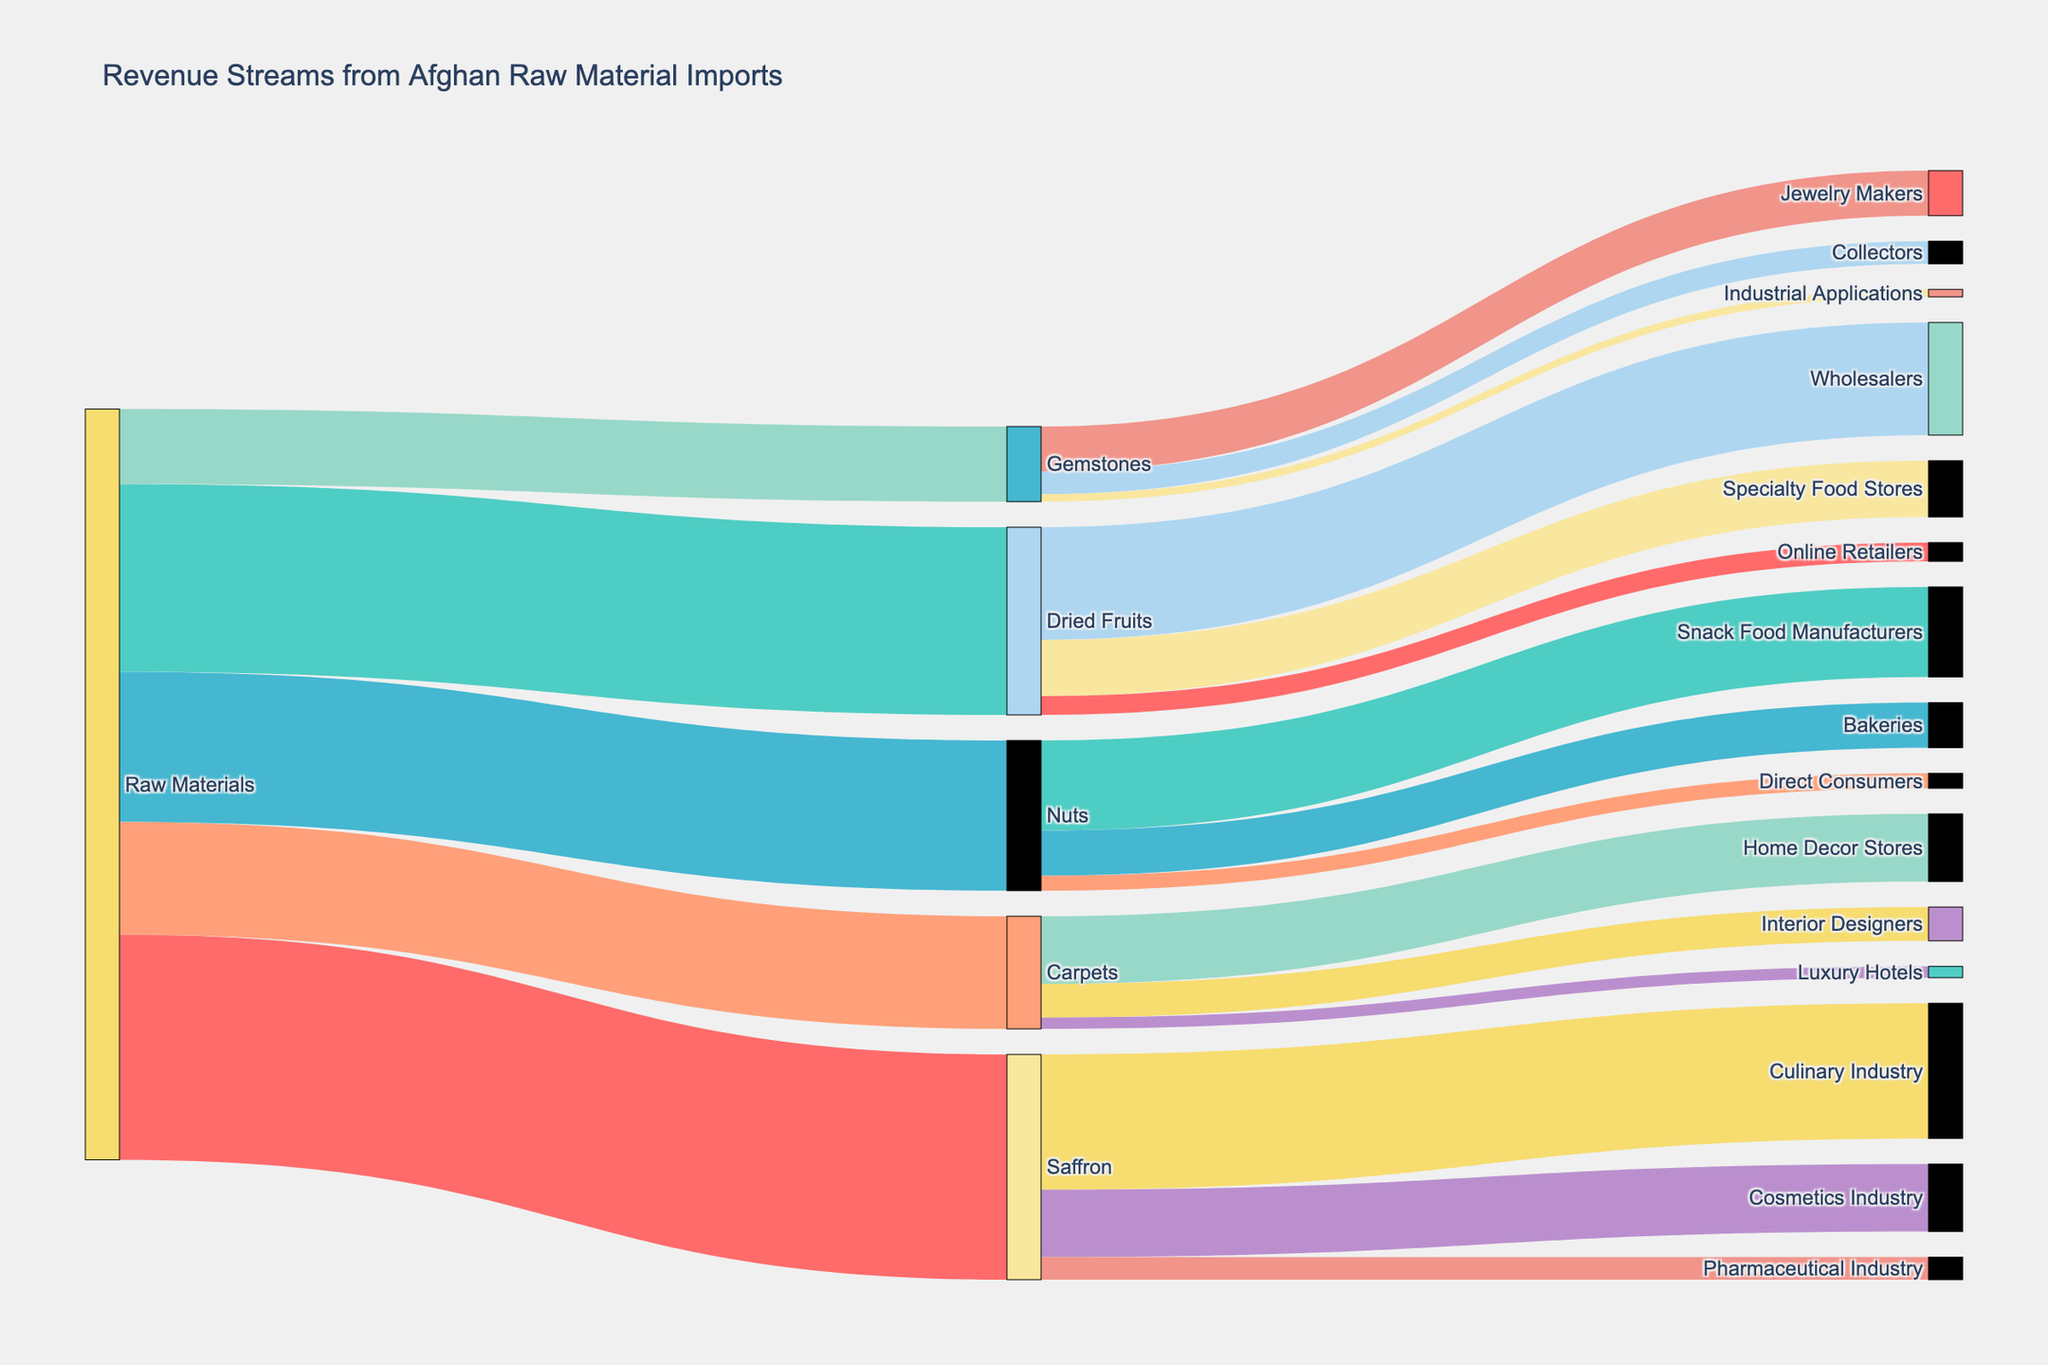what is the title of the figure? The title is usually displayed at the top of the figure. In this case, it clearly states "Revenue Streams from Afghan Raw Material Imports".
Answer: Revenue Streams from Afghan Raw Material Imports What is the total revenue generated from Saffron? To find the total revenue, look at the links branching out from Saffron and sum their values: 180,000 (Culinary Industry) + 90,000 (Cosmetics Industry) + 30,000 (Pharmaceutical Industry).
Answer: 300,000 Which product line generates the least revenue? Compare the values associated with each product line sourced from Raw Materials, which are 300,000 (Saffron), 250,000 (Dried Fruits), 200,000 (Nuts), 150,000 (Carpets), and 100,000 (Gemstones). The product line with the lowest number is 100,000.
Answer: Gemstones How does the revenue from Dried Fruits distribute among different targets? Look at the connections originating from Dried Fruits which show the revenue distribution: 150,000 (Wholesalers), 75,000 (Specialty Food Stores), and 25,000 (Online Retailers).
Answer: Wholesalers: 150,000, Specialty Food Stores: 75,000, Online Retailers: 25,000 What is the combined revenue for all industrial applications across different product lines? Sum the revenues of all connections to Industrial Applications: Only Gemstones contribute 10,000 to Industrial Applications.
Answer: 10,000 Which industry receives the most revenue from Saffron? Look at the values for all links directing from Saffron to various industries: Culinary Industry (180,000), Cosmetics Industry (90,000), and Pharmaceutical Industry (30,000). The highest value is 180,000.
Answer: Culinary Industry How does the revenue generated from Nuts compare to that from Carpets? Compare the values from Nuts (200,000) and Carpets (150,000). Nuts generate more revenue than Carpets.
Answer: Nuts generate more revenue than Carpets What is the total revenue from all raw materials imported? Add up all the values connected to Raw Materials: 300,000 (Saffron) + 250,000 (Dried Fruits) + 200,000 (Nuts) + 150,000 (Carpets) + 100,000 (Gemstones).
Answer: 1,000,000 Which product line has a more diverse set of targets for its revenue stream, Saffron or Carpets? Saffron has 3 targets (Culinary, Cosmetics, Pharmaceutical), while Carpets has 3 targets (Home Decor Stores, Interior Designers, Luxury Hotels). Both product lines have the same number of targets.
Answer: Saffron and Carpets both have 3 targets 